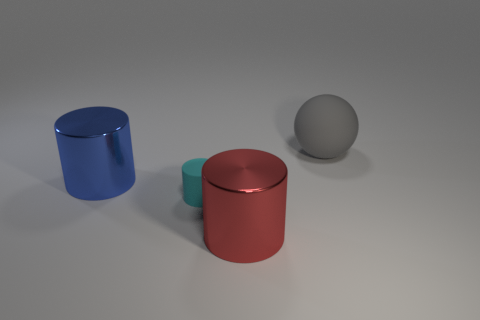Subtract all cyan cylinders. How many cylinders are left? 2 Subtract all cyan cylinders. How many cylinders are left? 2 Add 1 small cyan cylinders. How many objects exist? 5 Subtract all cylinders. How many objects are left? 1 Add 3 big metal cylinders. How many big metal cylinders are left? 5 Add 2 big purple spheres. How many big purple spheres exist? 2 Subtract 0 gray cubes. How many objects are left? 4 Subtract 1 spheres. How many spheres are left? 0 Subtract all blue spheres. Subtract all gray blocks. How many spheres are left? 1 Subtract all gray cylinders. How many blue spheres are left? 0 